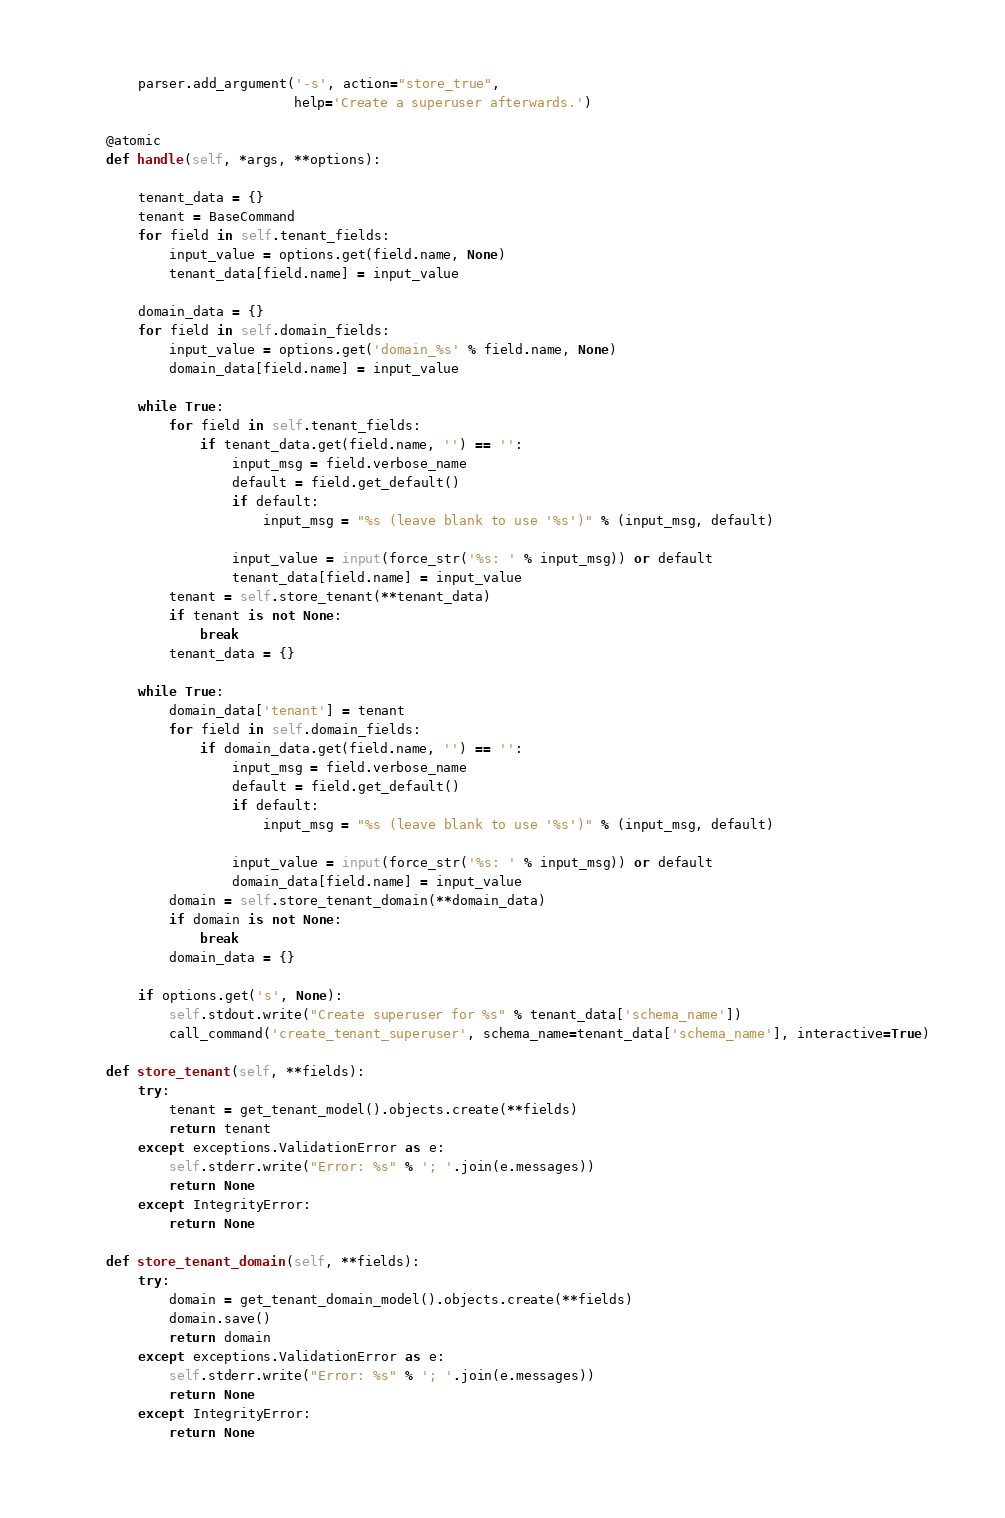<code> <loc_0><loc_0><loc_500><loc_500><_Python_>        parser.add_argument('-s', action="store_true",
                            help='Create a superuser afterwards.')

    @atomic
    def handle(self, *args, **options):

        tenant_data = {}
        tenant = BaseCommand
        for field in self.tenant_fields:
            input_value = options.get(field.name, None)
            tenant_data[field.name] = input_value

        domain_data = {}
        for field in self.domain_fields:
            input_value = options.get('domain_%s' % field.name, None)
            domain_data[field.name] = input_value

        while True:
            for field in self.tenant_fields:
                if tenant_data.get(field.name, '') == '':
                    input_msg = field.verbose_name
                    default = field.get_default()
                    if default:
                        input_msg = "%s (leave blank to use '%s')" % (input_msg, default)

                    input_value = input(force_str('%s: ' % input_msg)) or default
                    tenant_data[field.name] = input_value
            tenant = self.store_tenant(**tenant_data)
            if tenant is not None:
                break
            tenant_data = {}

        while True:
            domain_data['tenant'] = tenant
            for field in self.domain_fields:
                if domain_data.get(field.name, '') == '':
                    input_msg = field.verbose_name
                    default = field.get_default()
                    if default:
                        input_msg = "%s (leave blank to use '%s')" % (input_msg, default)

                    input_value = input(force_str('%s: ' % input_msg)) or default
                    domain_data[field.name] = input_value
            domain = self.store_tenant_domain(**domain_data)
            if domain is not None:
                break
            domain_data = {}

        if options.get('s', None):
            self.stdout.write("Create superuser for %s" % tenant_data['schema_name'])
            call_command('create_tenant_superuser', schema_name=tenant_data['schema_name'], interactive=True)

    def store_tenant(self, **fields):
        try:
            tenant = get_tenant_model().objects.create(**fields)
            return tenant
        except exceptions.ValidationError as e:
            self.stderr.write("Error: %s" % '; '.join(e.messages))
            return None
        except IntegrityError:
            return None

    def store_tenant_domain(self, **fields):
        try:
            domain = get_tenant_domain_model().objects.create(**fields)
            domain.save()
            return domain
        except exceptions.ValidationError as e:
            self.stderr.write("Error: %s" % '; '.join(e.messages))
            return None
        except IntegrityError:
            return None
</code> 